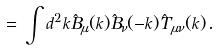Convert formula to latex. <formula><loc_0><loc_0><loc_500><loc_500>= \, \int d ^ { 2 } k \hat { B } _ { \mu } ( k ) \hat { B } _ { \nu } ( - k ) \hat { T } _ { \mu \nu } ( k ) \, .</formula> 